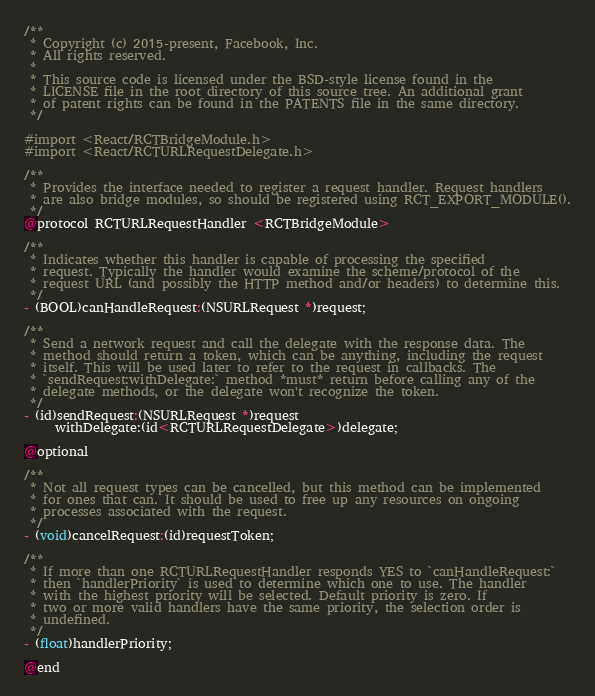Convert code to text. <code><loc_0><loc_0><loc_500><loc_500><_C_>/**
 * Copyright (c) 2015-present, Facebook, Inc.
 * All rights reserved.
 *
 * This source code is licensed under the BSD-style license found in the
 * LICENSE file in the root directory of this source tree. An additional grant
 * of patent rights can be found in the PATENTS file in the same directory.
 */

#import <React/RCTBridgeModule.h>
#import <React/RCTURLRequestDelegate.h>

/**
 * Provides the interface needed to register a request handler. Request handlers
 * are also bridge modules, so should be registered using RCT_EXPORT_MODULE().
 */
@protocol RCTURLRequestHandler <RCTBridgeModule>

/**
 * Indicates whether this handler is capable of processing the specified
 * request. Typically the handler would examine the scheme/protocol of the
 * request URL (and possibly the HTTP method and/or headers) to determine this.
 */
- (BOOL)canHandleRequest:(NSURLRequest *)request;

/**
 * Send a network request and call the delegate with the response data. The
 * method should return a token, which can be anything, including the request
 * itself. This will be used later to refer to the request in callbacks. The
 * `sendRequest:withDelegate:` method *must* return before calling any of the
 * delegate methods, or the delegate won't recognize the token.
 */
- (id)sendRequest:(NSURLRequest *)request
     withDelegate:(id<RCTURLRequestDelegate>)delegate;

@optional

/**
 * Not all request types can be cancelled, but this method can be implemented
 * for ones that can. It should be used to free up any resources on ongoing
 * processes associated with the request.
 */
- (void)cancelRequest:(id)requestToken;

/**
 * If more than one RCTURLRequestHandler responds YES to `canHandleRequest:`
 * then `handlerPriority` is used to determine which one to use. The handler
 * with the highest priority will be selected. Default priority is zero. If
 * two or more valid handlers have the same priority, the selection order is
 * undefined.
 */
- (float)handlerPriority;

@end
</code> 